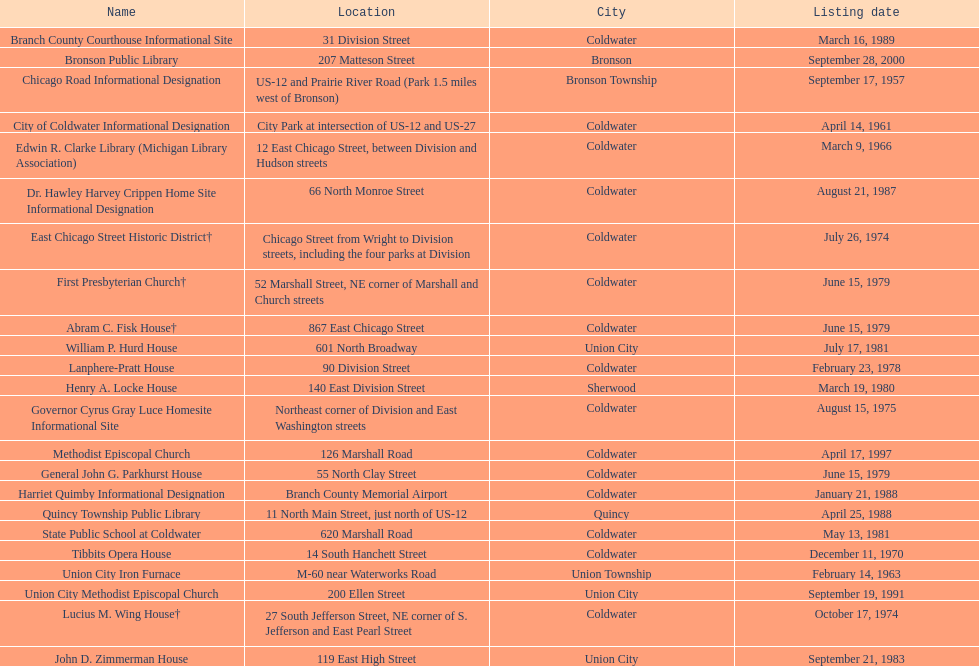Which city has the largest number of historic sites? Coldwater. 